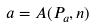<formula> <loc_0><loc_0><loc_500><loc_500>a = A ( P _ { a } , n )</formula> 